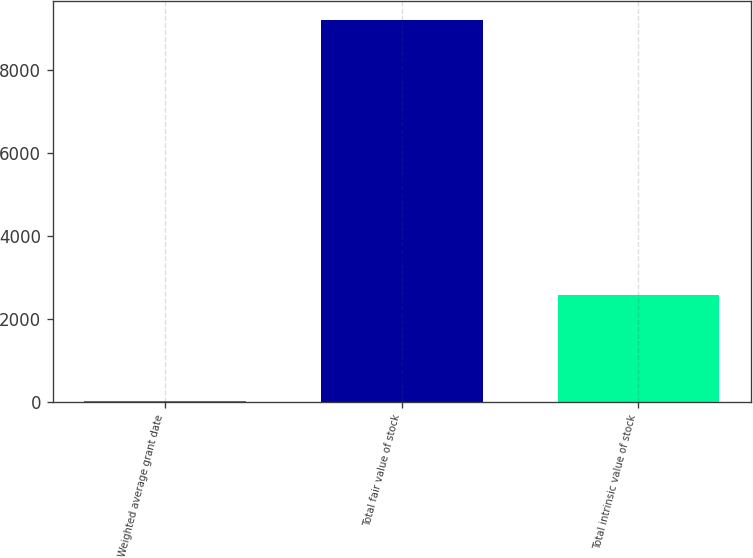<chart> <loc_0><loc_0><loc_500><loc_500><bar_chart><fcel>Weighted average grant date<fcel>Total fair value of stock<fcel>Total intrinsic value of stock<nl><fcel>14.54<fcel>9192<fcel>2561<nl></chart> 